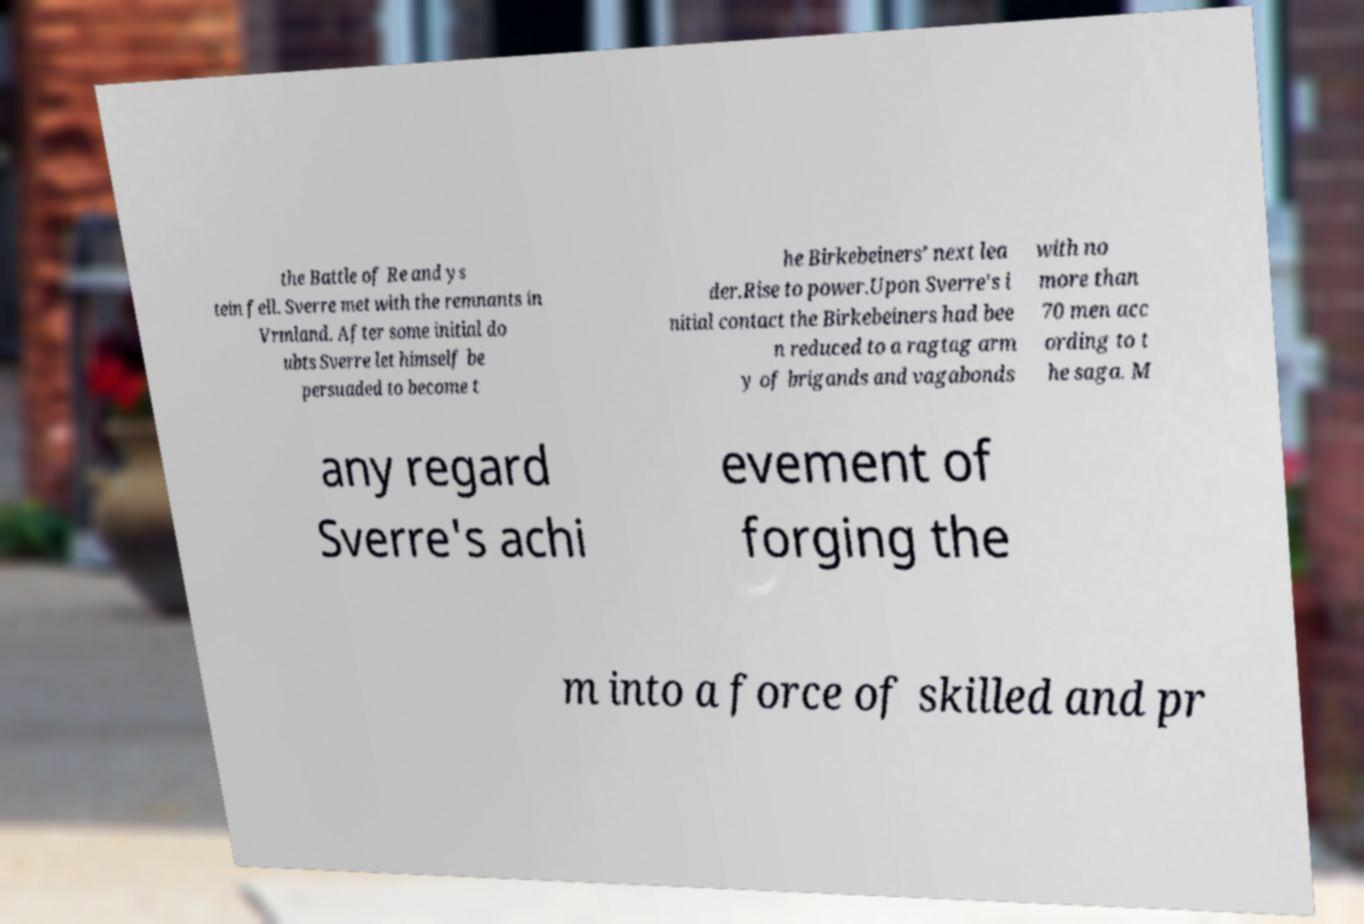Can you read and provide the text displayed in the image?This photo seems to have some interesting text. Can you extract and type it out for me? the Battle of Re and ys tein fell. Sverre met with the remnants in Vrmland. After some initial do ubts Sverre let himself be persuaded to become t he Birkebeiners’ next lea der.Rise to power.Upon Sverre's i nitial contact the Birkebeiners had bee n reduced to a ragtag arm y of brigands and vagabonds with no more than 70 men acc ording to t he saga. M any regard Sverre's achi evement of forging the m into a force of skilled and pr 